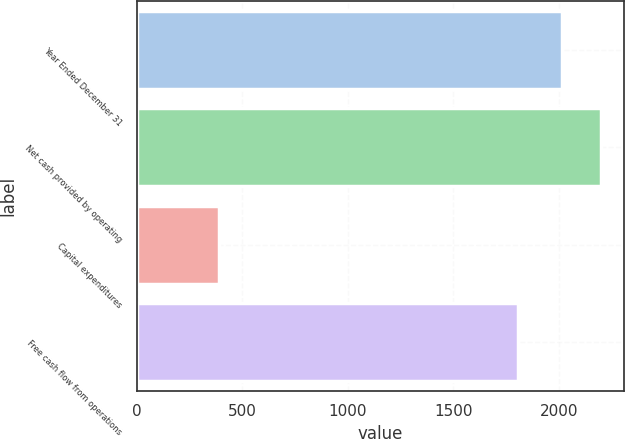Convert chart to OTSL. <chart><loc_0><loc_0><loc_500><loc_500><bar_chart><fcel>Year Ended December 31<fcel>Net cash provided by operating<fcel>Capital expenditures<fcel>Free cash flow from operations<nl><fcel>2016<fcel>2198<fcel>392<fcel>1806<nl></chart> 